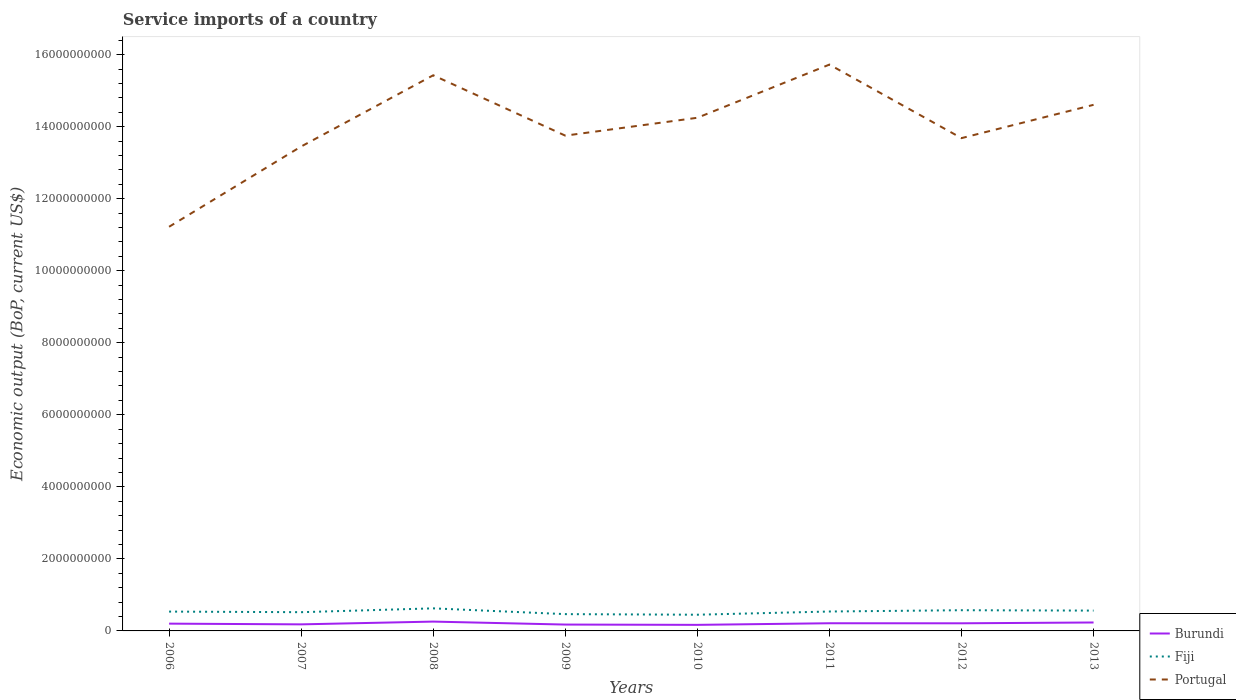Across all years, what is the maximum service imports in Fiji?
Your answer should be compact. 4.50e+08. In which year was the service imports in Portugal maximum?
Your response must be concise. 2006. What is the total service imports in Portugal in the graph?
Offer a very short reply. -4.96e+08. What is the difference between the highest and the second highest service imports in Portugal?
Offer a terse response. 4.50e+09. What is the difference between the highest and the lowest service imports in Fiji?
Offer a very short reply. 5. Is the service imports in Portugal strictly greater than the service imports in Fiji over the years?
Make the answer very short. No. How many lines are there?
Ensure brevity in your answer.  3. How many years are there in the graph?
Offer a terse response. 8. What is the difference between two consecutive major ticks on the Y-axis?
Offer a terse response. 2.00e+09. Does the graph contain any zero values?
Your answer should be very brief. No. Does the graph contain grids?
Keep it short and to the point. No. Where does the legend appear in the graph?
Ensure brevity in your answer.  Bottom right. What is the title of the graph?
Offer a terse response. Service imports of a country. Does "Gambia, The" appear as one of the legend labels in the graph?
Provide a succinct answer. No. What is the label or title of the Y-axis?
Make the answer very short. Economic output (BoP, current US$). What is the Economic output (BoP, current US$) in Burundi in 2006?
Ensure brevity in your answer.  2.02e+08. What is the Economic output (BoP, current US$) in Fiji in 2006?
Provide a succinct answer. 5.37e+08. What is the Economic output (BoP, current US$) of Portugal in 2006?
Offer a very short reply. 1.12e+1. What is the Economic output (BoP, current US$) of Burundi in 2007?
Offer a terse response. 1.82e+08. What is the Economic output (BoP, current US$) in Fiji in 2007?
Your answer should be very brief. 5.20e+08. What is the Economic output (BoP, current US$) of Portugal in 2007?
Ensure brevity in your answer.  1.34e+1. What is the Economic output (BoP, current US$) of Burundi in 2008?
Provide a short and direct response. 2.59e+08. What is the Economic output (BoP, current US$) of Fiji in 2008?
Give a very brief answer. 6.27e+08. What is the Economic output (BoP, current US$) in Portugal in 2008?
Your response must be concise. 1.54e+1. What is the Economic output (BoP, current US$) in Burundi in 2009?
Offer a terse response. 1.77e+08. What is the Economic output (BoP, current US$) in Fiji in 2009?
Your answer should be compact. 4.66e+08. What is the Economic output (BoP, current US$) of Portugal in 2009?
Offer a terse response. 1.38e+1. What is the Economic output (BoP, current US$) in Burundi in 2010?
Your answer should be very brief. 1.68e+08. What is the Economic output (BoP, current US$) in Fiji in 2010?
Offer a very short reply. 4.50e+08. What is the Economic output (BoP, current US$) in Portugal in 2010?
Give a very brief answer. 1.42e+1. What is the Economic output (BoP, current US$) of Burundi in 2011?
Your answer should be compact. 2.13e+08. What is the Economic output (BoP, current US$) in Fiji in 2011?
Ensure brevity in your answer.  5.39e+08. What is the Economic output (BoP, current US$) in Portugal in 2011?
Offer a terse response. 1.57e+1. What is the Economic output (BoP, current US$) of Burundi in 2012?
Make the answer very short. 2.12e+08. What is the Economic output (BoP, current US$) of Fiji in 2012?
Make the answer very short. 5.75e+08. What is the Economic output (BoP, current US$) of Portugal in 2012?
Make the answer very short. 1.37e+1. What is the Economic output (BoP, current US$) in Burundi in 2013?
Your answer should be very brief. 2.34e+08. What is the Economic output (BoP, current US$) in Fiji in 2013?
Make the answer very short. 5.64e+08. What is the Economic output (BoP, current US$) in Portugal in 2013?
Your response must be concise. 1.46e+1. Across all years, what is the maximum Economic output (BoP, current US$) in Burundi?
Your response must be concise. 2.59e+08. Across all years, what is the maximum Economic output (BoP, current US$) in Fiji?
Offer a terse response. 6.27e+08. Across all years, what is the maximum Economic output (BoP, current US$) of Portugal?
Ensure brevity in your answer.  1.57e+1. Across all years, what is the minimum Economic output (BoP, current US$) of Burundi?
Give a very brief answer. 1.68e+08. Across all years, what is the minimum Economic output (BoP, current US$) of Fiji?
Offer a terse response. 4.50e+08. Across all years, what is the minimum Economic output (BoP, current US$) in Portugal?
Keep it short and to the point. 1.12e+1. What is the total Economic output (BoP, current US$) of Burundi in the graph?
Offer a terse response. 1.65e+09. What is the total Economic output (BoP, current US$) in Fiji in the graph?
Give a very brief answer. 4.28e+09. What is the total Economic output (BoP, current US$) of Portugal in the graph?
Your answer should be compact. 1.12e+11. What is the difference between the Economic output (BoP, current US$) in Burundi in 2006 and that in 2007?
Offer a very short reply. 2.01e+07. What is the difference between the Economic output (BoP, current US$) of Fiji in 2006 and that in 2007?
Keep it short and to the point. 1.64e+07. What is the difference between the Economic output (BoP, current US$) of Portugal in 2006 and that in 2007?
Ensure brevity in your answer.  -2.23e+09. What is the difference between the Economic output (BoP, current US$) of Burundi in 2006 and that in 2008?
Provide a succinct answer. -5.65e+07. What is the difference between the Economic output (BoP, current US$) in Fiji in 2006 and that in 2008?
Offer a very short reply. -8.98e+07. What is the difference between the Economic output (BoP, current US$) in Portugal in 2006 and that in 2008?
Offer a very short reply. -4.21e+09. What is the difference between the Economic output (BoP, current US$) in Burundi in 2006 and that in 2009?
Make the answer very short. 2.56e+07. What is the difference between the Economic output (BoP, current US$) of Fiji in 2006 and that in 2009?
Ensure brevity in your answer.  7.06e+07. What is the difference between the Economic output (BoP, current US$) of Portugal in 2006 and that in 2009?
Make the answer very short. -2.53e+09. What is the difference between the Economic output (BoP, current US$) in Burundi in 2006 and that in 2010?
Your answer should be very brief. 3.39e+07. What is the difference between the Economic output (BoP, current US$) in Fiji in 2006 and that in 2010?
Give a very brief answer. 8.69e+07. What is the difference between the Economic output (BoP, current US$) of Portugal in 2006 and that in 2010?
Provide a short and direct response. -3.03e+09. What is the difference between the Economic output (BoP, current US$) of Burundi in 2006 and that in 2011?
Your response must be concise. -1.06e+07. What is the difference between the Economic output (BoP, current US$) of Fiji in 2006 and that in 2011?
Offer a terse response. -2.33e+06. What is the difference between the Economic output (BoP, current US$) of Portugal in 2006 and that in 2011?
Your answer should be compact. -4.50e+09. What is the difference between the Economic output (BoP, current US$) in Burundi in 2006 and that in 2012?
Your response must be concise. -9.36e+06. What is the difference between the Economic output (BoP, current US$) in Fiji in 2006 and that in 2012?
Your answer should be compact. -3.81e+07. What is the difference between the Economic output (BoP, current US$) of Portugal in 2006 and that in 2012?
Your answer should be very brief. -2.46e+09. What is the difference between the Economic output (BoP, current US$) in Burundi in 2006 and that in 2013?
Your answer should be compact. -3.19e+07. What is the difference between the Economic output (BoP, current US$) of Fiji in 2006 and that in 2013?
Your answer should be compact. -2.76e+07. What is the difference between the Economic output (BoP, current US$) in Portugal in 2006 and that in 2013?
Make the answer very short. -3.39e+09. What is the difference between the Economic output (BoP, current US$) of Burundi in 2007 and that in 2008?
Ensure brevity in your answer.  -7.66e+07. What is the difference between the Economic output (BoP, current US$) in Fiji in 2007 and that in 2008?
Your answer should be very brief. -1.06e+08. What is the difference between the Economic output (BoP, current US$) of Portugal in 2007 and that in 2008?
Make the answer very short. -1.98e+09. What is the difference between the Economic output (BoP, current US$) of Burundi in 2007 and that in 2009?
Your answer should be compact. 5.50e+06. What is the difference between the Economic output (BoP, current US$) in Fiji in 2007 and that in 2009?
Offer a terse response. 5.41e+07. What is the difference between the Economic output (BoP, current US$) of Portugal in 2007 and that in 2009?
Your response must be concise. -3.01e+08. What is the difference between the Economic output (BoP, current US$) in Burundi in 2007 and that in 2010?
Provide a succinct answer. 1.38e+07. What is the difference between the Economic output (BoP, current US$) in Fiji in 2007 and that in 2010?
Offer a terse response. 7.04e+07. What is the difference between the Economic output (BoP, current US$) in Portugal in 2007 and that in 2010?
Keep it short and to the point. -7.98e+08. What is the difference between the Economic output (BoP, current US$) of Burundi in 2007 and that in 2011?
Give a very brief answer. -3.07e+07. What is the difference between the Economic output (BoP, current US$) in Fiji in 2007 and that in 2011?
Offer a very short reply. -1.88e+07. What is the difference between the Economic output (BoP, current US$) in Portugal in 2007 and that in 2011?
Keep it short and to the point. -2.27e+09. What is the difference between the Economic output (BoP, current US$) of Burundi in 2007 and that in 2012?
Ensure brevity in your answer.  -2.95e+07. What is the difference between the Economic output (BoP, current US$) in Fiji in 2007 and that in 2012?
Make the answer very short. -5.45e+07. What is the difference between the Economic output (BoP, current US$) in Portugal in 2007 and that in 2012?
Make the answer very short. -2.32e+08. What is the difference between the Economic output (BoP, current US$) in Burundi in 2007 and that in 2013?
Keep it short and to the point. -5.20e+07. What is the difference between the Economic output (BoP, current US$) in Fiji in 2007 and that in 2013?
Ensure brevity in your answer.  -4.41e+07. What is the difference between the Economic output (BoP, current US$) in Portugal in 2007 and that in 2013?
Offer a very short reply. -1.16e+09. What is the difference between the Economic output (BoP, current US$) in Burundi in 2008 and that in 2009?
Provide a succinct answer. 8.21e+07. What is the difference between the Economic output (BoP, current US$) of Fiji in 2008 and that in 2009?
Offer a terse response. 1.60e+08. What is the difference between the Economic output (BoP, current US$) in Portugal in 2008 and that in 2009?
Provide a succinct answer. 1.68e+09. What is the difference between the Economic output (BoP, current US$) in Burundi in 2008 and that in 2010?
Keep it short and to the point. 9.04e+07. What is the difference between the Economic output (BoP, current US$) in Fiji in 2008 and that in 2010?
Your answer should be very brief. 1.77e+08. What is the difference between the Economic output (BoP, current US$) of Portugal in 2008 and that in 2010?
Make the answer very short. 1.18e+09. What is the difference between the Economic output (BoP, current US$) of Burundi in 2008 and that in 2011?
Provide a succinct answer. 4.59e+07. What is the difference between the Economic output (BoP, current US$) in Fiji in 2008 and that in 2011?
Offer a terse response. 8.75e+07. What is the difference between the Economic output (BoP, current US$) in Portugal in 2008 and that in 2011?
Offer a very short reply. -2.97e+08. What is the difference between the Economic output (BoP, current US$) in Burundi in 2008 and that in 2012?
Provide a short and direct response. 4.72e+07. What is the difference between the Economic output (BoP, current US$) in Fiji in 2008 and that in 2012?
Make the answer very short. 5.17e+07. What is the difference between the Economic output (BoP, current US$) in Portugal in 2008 and that in 2012?
Keep it short and to the point. 1.74e+09. What is the difference between the Economic output (BoP, current US$) in Burundi in 2008 and that in 2013?
Your response must be concise. 2.46e+07. What is the difference between the Economic output (BoP, current US$) in Fiji in 2008 and that in 2013?
Offer a very short reply. 6.22e+07. What is the difference between the Economic output (BoP, current US$) in Portugal in 2008 and that in 2013?
Give a very brief answer. 8.20e+08. What is the difference between the Economic output (BoP, current US$) in Burundi in 2009 and that in 2010?
Your answer should be compact. 8.29e+06. What is the difference between the Economic output (BoP, current US$) of Fiji in 2009 and that in 2010?
Give a very brief answer. 1.63e+07. What is the difference between the Economic output (BoP, current US$) of Portugal in 2009 and that in 2010?
Provide a short and direct response. -4.96e+08. What is the difference between the Economic output (BoP, current US$) in Burundi in 2009 and that in 2011?
Provide a succinct answer. -3.62e+07. What is the difference between the Economic output (BoP, current US$) in Fiji in 2009 and that in 2011?
Your response must be concise. -7.29e+07. What is the difference between the Economic output (BoP, current US$) of Portugal in 2009 and that in 2011?
Your answer should be very brief. -1.97e+09. What is the difference between the Economic output (BoP, current US$) of Burundi in 2009 and that in 2012?
Your answer should be compact. -3.49e+07. What is the difference between the Economic output (BoP, current US$) of Fiji in 2009 and that in 2012?
Give a very brief answer. -1.09e+08. What is the difference between the Economic output (BoP, current US$) of Portugal in 2009 and that in 2012?
Offer a very short reply. 6.92e+07. What is the difference between the Economic output (BoP, current US$) of Burundi in 2009 and that in 2013?
Ensure brevity in your answer.  -5.75e+07. What is the difference between the Economic output (BoP, current US$) in Fiji in 2009 and that in 2013?
Provide a short and direct response. -9.82e+07. What is the difference between the Economic output (BoP, current US$) in Portugal in 2009 and that in 2013?
Your response must be concise. -8.56e+08. What is the difference between the Economic output (BoP, current US$) of Burundi in 2010 and that in 2011?
Offer a very short reply. -4.45e+07. What is the difference between the Economic output (BoP, current US$) in Fiji in 2010 and that in 2011?
Offer a terse response. -8.92e+07. What is the difference between the Economic output (BoP, current US$) in Portugal in 2010 and that in 2011?
Offer a terse response. -1.48e+09. What is the difference between the Economic output (BoP, current US$) of Burundi in 2010 and that in 2012?
Your answer should be compact. -4.32e+07. What is the difference between the Economic output (BoP, current US$) of Fiji in 2010 and that in 2012?
Ensure brevity in your answer.  -1.25e+08. What is the difference between the Economic output (BoP, current US$) of Portugal in 2010 and that in 2012?
Offer a terse response. 5.66e+08. What is the difference between the Economic output (BoP, current US$) in Burundi in 2010 and that in 2013?
Ensure brevity in your answer.  -6.58e+07. What is the difference between the Economic output (BoP, current US$) in Fiji in 2010 and that in 2013?
Offer a very short reply. -1.14e+08. What is the difference between the Economic output (BoP, current US$) of Portugal in 2010 and that in 2013?
Offer a very short reply. -3.59e+08. What is the difference between the Economic output (BoP, current US$) of Burundi in 2011 and that in 2012?
Ensure brevity in your answer.  1.27e+06. What is the difference between the Economic output (BoP, current US$) in Fiji in 2011 and that in 2012?
Your answer should be very brief. -3.57e+07. What is the difference between the Economic output (BoP, current US$) in Portugal in 2011 and that in 2012?
Give a very brief answer. 2.04e+09. What is the difference between the Economic output (BoP, current US$) in Burundi in 2011 and that in 2013?
Keep it short and to the point. -2.13e+07. What is the difference between the Economic output (BoP, current US$) of Fiji in 2011 and that in 2013?
Keep it short and to the point. -2.53e+07. What is the difference between the Economic output (BoP, current US$) of Portugal in 2011 and that in 2013?
Your answer should be very brief. 1.12e+09. What is the difference between the Economic output (BoP, current US$) in Burundi in 2012 and that in 2013?
Your answer should be very brief. -2.26e+07. What is the difference between the Economic output (BoP, current US$) of Fiji in 2012 and that in 2013?
Provide a short and direct response. 1.05e+07. What is the difference between the Economic output (BoP, current US$) of Portugal in 2012 and that in 2013?
Keep it short and to the point. -9.25e+08. What is the difference between the Economic output (BoP, current US$) in Burundi in 2006 and the Economic output (BoP, current US$) in Fiji in 2007?
Provide a short and direct response. -3.18e+08. What is the difference between the Economic output (BoP, current US$) in Burundi in 2006 and the Economic output (BoP, current US$) in Portugal in 2007?
Your answer should be compact. -1.32e+1. What is the difference between the Economic output (BoP, current US$) in Fiji in 2006 and the Economic output (BoP, current US$) in Portugal in 2007?
Offer a very short reply. -1.29e+1. What is the difference between the Economic output (BoP, current US$) in Burundi in 2006 and the Economic output (BoP, current US$) in Fiji in 2008?
Offer a very short reply. -4.24e+08. What is the difference between the Economic output (BoP, current US$) of Burundi in 2006 and the Economic output (BoP, current US$) of Portugal in 2008?
Ensure brevity in your answer.  -1.52e+1. What is the difference between the Economic output (BoP, current US$) in Fiji in 2006 and the Economic output (BoP, current US$) in Portugal in 2008?
Make the answer very short. -1.49e+1. What is the difference between the Economic output (BoP, current US$) in Burundi in 2006 and the Economic output (BoP, current US$) in Fiji in 2009?
Provide a short and direct response. -2.64e+08. What is the difference between the Economic output (BoP, current US$) of Burundi in 2006 and the Economic output (BoP, current US$) of Portugal in 2009?
Your response must be concise. -1.35e+1. What is the difference between the Economic output (BoP, current US$) in Fiji in 2006 and the Economic output (BoP, current US$) in Portugal in 2009?
Your answer should be very brief. -1.32e+1. What is the difference between the Economic output (BoP, current US$) of Burundi in 2006 and the Economic output (BoP, current US$) of Fiji in 2010?
Keep it short and to the point. -2.48e+08. What is the difference between the Economic output (BoP, current US$) in Burundi in 2006 and the Economic output (BoP, current US$) in Portugal in 2010?
Your response must be concise. -1.40e+1. What is the difference between the Economic output (BoP, current US$) in Fiji in 2006 and the Economic output (BoP, current US$) in Portugal in 2010?
Offer a terse response. -1.37e+1. What is the difference between the Economic output (BoP, current US$) of Burundi in 2006 and the Economic output (BoP, current US$) of Fiji in 2011?
Give a very brief answer. -3.37e+08. What is the difference between the Economic output (BoP, current US$) in Burundi in 2006 and the Economic output (BoP, current US$) in Portugal in 2011?
Your answer should be compact. -1.55e+1. What is the difference between the Economic output (BoP, current US$) in Fiji in 2006 and the Economic output (BoP, current US$) in Portugal in 2011?
Provide a succinct answer. -1.52e+1. What is the difference between the Economic output (BoP, current US$) of Burundi in 2006 and the Economic output (BoP, current US$) of Fiji in 2012?
Offer a very short reply. -3.73e+08. What is the difference between the Economic output (BoP, current US$) of Burundi in 2006 and the Economic output (BoP, current US$) of Portugal in 2012?
Your response must be concise. -1.35e+1. What is the difference between the Economic output (BoP, current US$) of Fiji in 2006 and the Economic output (BoP, current US$) of Portugal in 2012?
Keep it short and to the point. -1.31e+1. What is the difference between the Economic output (BoP, current US$) in Burundi in 2006 and the Economic output (BoP, current US$) in Fiji in 2013?
Your answer should be compact. -3.62e+08. What is the difference between the Economic output (BoP, current US$) of Burundi in 2006 and the Economic output (BoP, current US$) of Portugal in 2013?
Provide a succinct answer. -1.44e+1. What is the difference between the Economic output (BoP, current US$) in Fiji in 2006 and the Economic output (BoP, current US$) in Portugal in 2013?
Make the answer very short. -1.41e+1. What is the difference between the Economic output (BoP, current US$) of Burundi in 2007 and the Economic output (BoP, current US$) of Fiji in 2008?
Provide a short and direct response. -4.44e+08. What is the difference between the Economic output (BoP, current US$) of Burundi in 2007 and the Economic output (BoP, current US$) of Portugal in 2008?
Your response must be concise. -1.52e+1. What is the difference between the Economic output (BoP, current US$) of Fiji in 2007 and the Economic output (BoP, current US$) of Portugal in 2008?
Provide a succinct answer. -1.49e+1. What is the difference between the Economic output (BoP, current US$) of Burundi in 2007 and the Economic output (BoP, current US$) of Fiji in 2009?
Ensure brevity in your answer.  -2.84e+08. What is the difference between the Economic output (BoP, current US$) in Burundi in 2007 and the Economic output (BoP, current US$) in Portugal in 2009?
Your response must be concise. -1.36e+1. What is the difference between the Economic output (BoP, current US$) of Fiji in 2007 and the Economic output (BoP, current US$) of Portugal in 2009?
Ensure brevity in your answer.  -1.32e+1. What is the difference between the Economic output (BoP, current US$) in Burundi in 2007 and the Economic output (BoP, current US$) in Fiji in 2010?
Provide a short and direct response. -2.68e+08. What is the difference between the Economic output (BoP, current US$) of Burundi in 2007 and the Economic output (BoP, current US$) of Portugal in 2010?
Provide a short and direct response. -1.41e+1. What is the difference between the Economic output (BoP, current US$) of Fiji in 2007 and the Economic output (BoP, current US$) of Portugal in 2010?
Offer a terse response. -1.37e+1. What is the difference between the Economic output (BoP, current US$) in Burundi in 2007 and the Economic output (BoP, current US$) in Fiji in 2011?
Your response must be concise. -3.57e+08. What is the difference between the Economic output (BoP, current US$) in Burundi in 2007 and the Economic output (BoP, current US$) in Portugal in 2011?
Make the answer very short. -1.55e+1. What is the difference between the Economic output (BoP, current US$) in Fiji in 2007 and the Economic output (BoP, current US$) in Portugal in 2011?
Your response must be concise. -1.52e+1. What is the difference between the Economic output (BoP, current US$) of Burundi in 2007 and the Economic output (BoP, current US$) of Fiji in 2012?
Offer a very short reply. -3.93e+08. What is the difference between the Economic output (BoP, current US$) of Burundi in 2007 and the Economic output (BoP, current US$) of Portugal in 2012?
Ensure brevity in your answer.  -1.35e+1. What is the difference between the Economic output (BoP, current US$) of Fiji in 2007 and the Economic output (BoP, current US$) of Portugal in 2012?
Make the answer very short. -1.32e+1. What is the difference between the Economic output (BoP, current US$) in Burundi in 2007 and the Economic output (BoP, current US$) in Fiji in 2013?
Offer a terse response. -3.82e+08. What is the difference between the Economic output (BoP, current US$) of Burundi in 2007 and the Economic output (BoP, current US$) of Portugal in 2013?
Make the answer very short. -1.44e+1. What is the difference between the Economic output (BoP, current US$) in Fiji in 2007 and the Economic output (BoP, current US$) in Portugal in 2013?
Your answer should be compact. -1.41e+1. What is the difference between the Economic output (BoP, current US$) of Burundi in 2008 and the Economic output (BoP, current US$) of Fiji in 2009?
Offer a very short reply. -2.07e+08. What is the difference between the Economic output (BoP, current US$) of Burundi in 2008 and the Economic output (BoP, current US$) of Portugal in 2009?
Give a very brief answer. -1.35e+1. What is the difference between the Economic output (BoP, current US$) in Fiji in 2008 and the Economic output (BoP, current US$) in Portugal in 2009?
Make the answer very short. -1.31e+1. What is the difference between the Economic output (BoP, current US$) in Burundi in 2008 and the Economic output (BoP, current US$) in Fiji in 2010?
Offer a very short reply. -1.91e+08. What is the difference between the Economic output (BoP, current US$) of Burundi in 2008 and the Economic output (BoP, current US$) of Portugal in 2010?
Your answer should be very brief. -1.40e+1. What is the difference between the Economic output (BoP, current US$) of Fiji in 2008 and the Economic output (BoP, current US$) of Portugal in 2010?
Offer a very short reply. -1.36e+1. What is the difference between the Economic output (BoP, current US$) of Burundi in 2008 and the Economic output (BoP, current US$) of Fiji in 2011?
Keep it short and to the point. -2.80e+08. What is the difference between the Economic output (BoP, current US$) in Burundi in 2008 and the Economic output (BoP, current US$) in Portugal in 2011?
Provide a succinct answer. -1.55e+1. What is the difference between the Economic output (BoP, current US$) of Fiji in 2008 and the Economic output (BoP, current US$) of Portugal in 2011?
Your answer should be compact. -1.51e+1. What is the difference between the Economic output (BoP, current US$) of Burundi in 2008 and the Economic output (BoP, current US$) of Fiji in 2012?
Offer a terse response. -3.16e+08. What is the difference between the Economic output (BoP, current US$) in Burundi in 2008 and the Economic output (BoP, current US$) in Portugal in 2012?
Give a very brief answer. -1.34e+1. What is the difference between the Economic output (BoP, current US$) in Fiji in 2008 and the Economic output (BoP, current US$) in Portugal in 2012?
Your answer should be compact. -1.31e+1. What is the difference between the Economic output (BoP, current US$) of Burundi in 2008 and the Economic output (BoP, current US$) of Fiji in 2013?
Keep it short and to the point. -3.06e+08. What is the difference between the Economic output (BoP, current US$) of Burundi in 2008 and the Economic output (BoP, current US$) of Portugal in 2013?
Offer a very short reply. -1.43e+1. What is the difference between the Economic output (BoP, current US$) of Fiji in 2008 and the Economic output (BoP, current US$) of Portugal in 2013?
Provide a short and direct response. -1.40e+1. What is the difference between the Economic output (BoP, current US$) of Burundi in 2009 and the Economic output (BoP, current US$) of Fiji in 2010?
Give a very brief answer. -2.73e+08. What is the difference between the Economic output (BoP, current US$) in Burundi in 2009 and the Economic output (BoP, current US$) in Portugal in 2010?
Offer a terse response. -1.41e+1. What is the difference between the Economic output (BoP, current US$) of Fiji in 2009 and the Economic output (BoP, current US$) of Portugal in 2010?
Provide a short and direct response. -1.38e+1. What is the difference between the Economic output (BoP, current US$) of Burundi in 2009 and the Economic output (BoP, current US$) of Fiji in 2011?
Offer a very short reply. -3.62e+08. What is the difference between the Economic output (BoP, current US$) of Burundi in 2009 and the Economic output (BoP, current US$) of Portugal in 2011?
Provide a succinct answer. -1.55e+1. What is the difference between the Economic output (BoP, current US$) in Fiji in 2009 and the Economic output (BoP, current US$) in Portugal in 2011?
Offer a terse response. -1.53e+1. What is the difference between the Economic output (BoP, current US$) of Burundi in 2009 and the Economic output (BoP, current US$) of Fiji in 2012?
Your response must be concise. -3.98e+08. What is the difference between the Economic output (BoP, current US$) of Burundi in 2009 and the Economic output (BoP, current US$) of Portugal in 2012?
Make the answer very short. -1.35e+1. What is the difference between the Economic output (BoP, current US$) of Fiji in 2009 and the Economic output (BoP, current US$) of Portugal in 2012?
Offer a terse response. -1.32e+1. What is the difference between the Economic output (BoP, current US$) in Burundi in 2009 and the Economic output (BoP, current US$) in Fiji in 2013?
Your answer should be compact. -3.88e+08. What is the difference between the Economic output (BoP, current US$) of Burundi in 2009 and the Economic output (BoP, current US$) of Portugal in 2013?
Keep it short and to the point. -1.44e+1. What is the difference between the Economic output (BoP, current US$) of Fiji in 2009 and the Economic output (BoP, current US$) of Portugal in 2013?
Your response must be concise. -1.41e+1. What is the difference between the Economic output (BoP, current US$) of Burundi in 2010 and the Economic output (BoP, current US$) of Fiji in 2011?
Provide a short and direct response. -3.71e+08. What is the difference between the Economic output (BoP, current US$) in Burundi in 2010 and the Economic output (BoP, current US$) in Portugal in 2011?
Your answer should be compact. -1.56e+1. What is the difference between the Economic output (BoP, current US$) of Fiji in 2010 and the Economic output (BoP, current US$) of Portugal in 2011?
Your answer should be compact. -1.53e+1. What is the difference between the Economic output (BoP, current US$) in Burundi in 2010 and the Economic output (BoP, current US$) in Fiji in 2012?
Make the answer very short. -4.06e+08. What is the difference between the Economic output (BoP, current US$) of Burundi in 2010 and the Economic output (BoP, current US$) of Portugal in 2012?
Provide a short and direct response. -1.35e+1. What is the difference between the Economic output (BoP, current US$) of Fiji in 2010 and the Economic output (BoP, current US$) of Portugal in 2012?
Your answer should be compact. -1.32e+1. What is the difference between the Economic output (BoP, current US$) in Burundi in 2010 and the Economic output (BoP, current US$) in Fiji in 2013?
Give a very brief answer. -3.96e+08. What is the difference between the Economic output (BoP, current US$) of Burundi in 2010 and the Economic output (BoP, current US$) of Portugal in 2013?
Provide a short and direct response. -1.44e+1. What is the difference between the Economic output (BoP, current US$) of Fiji in 2010 and the Economic output (BoP, current US$) of Portugal in 2013?
Your answer should be very brief. -1.42e+1. What is the difference between the Economic output (BoP, current US$) of Burundi in 2011 and the Economic output (BoP, current US$) of Fiji in 2012?
Your answer should be compact. -3.62e+08. What is the difference between the Economic output (BoP, current US$) of Burundi in 2011 and the Economic output (BoP, current US$) of Portugal in 2012?
Offer a terse response. -1.35e+1. What is the difference between the Economic output (BoP, current US$) of Fiji in 2011 and the Economic output (BoP, current US$) of Portugal in 2012?
Provide a succinct answer. -1.31e+1. What is the difference between the Economic output (BoP, current US$) in Burundi in 2011 and the Economic output (BoP, current US$) in Fiji in 2013?
Ensure brevity in your answer.  -3.51e+08. What is the difference between the Economic output (BoP, current US$) in Burundi in 2011 and the Economic output (BoP, current US$) in Portugal in 2013?
Make the answer very short. -1.44e+1. What is the difference between the Economic output (BoP, current US$) in Fiji in 2011 and the Economic output (BoP, current US$) in Portugal in 2013?
Provide a short and direct response. -1.41e+1. What is the difference between the Economic output (BoP, current US$) of Burundi in 2012 and the Economic output (BoP, current US$) of Fiji in 2013?
Your response must be concise. -3.53e+08. What is the difference between the Economic output (BoP, current US$) of Burundi in 2012 and the Economic output (BoP, current US$) of Portugal in 2013?
Keep it short and to the point. -1.44e+1. What is the difference between the Economic output (BoP, current US$) of Fiji in 2012 and the Economic output (BoP, current US$) of Portugal in 2013?
Your answer should be compact. -1.40e+1. What is the average Economic output (BoP, current US$) of Burundi per year?
Your response must be concise. 2.06e+08. What is the average Economic output (BoP, current US$) of Fiji per year?
Offer a terse response. 5.35e+08. What is the average Economic output (BoP, current US$) in Portugal per year?
Give a very brief answer. 1.40e+1. In the year 2006, what is the difference between the Economic output (BoP, current US$) in Burundi and Economic output (BoP, current US$) in Fiji?
Provide a short and direct response. -3.34e+08. In the year 2006, what is the difference between the Economic output (BoP, current US$) of Burundi and Economic output (BoP, current US$) of Portugal?
Provide a short and direct response. -1.10e+1. In the year 2006, what is the difference between the Economic output (BoP, current US$) of Fiji and Economic output (BoP, current US$) of Portugal?
Keep it short and to the point. -1.07e+1. In the year 2007, what is the difference between the Economic output (BoP, current US$) in Burundi and Economic output (BoP, current US$) in Fiji?
Provide a succinct answer. -3.38e+08. In the year 2007, what is the difference between the Economic output (BoP, current US$) of Burundi and Economic output (BoP, current US$) of Portugal?
Offer a terse response. -1.33e+1. In the year 2007, what is the difference between the Economic output (BoP, current US$) of Fiji and Economic output (BoP, current US$) of Portugal?
Provide a succinct answer. -1.29e+1. In the year 2008, what is the difference between the Economic output (BoP, current US$) in Burundi and Economic output (BoP, current US$) in Fiji?
Provide a short and direct response. -3.68e+08. In the year 2008, what is the difference between the Economic output (BoP, current US$) in Burundi and Economic output (BoP, current US$) in Portugal?
Make the answer very short. -1.52e+1. In the year 2008, what is the difference between the Economic output (BoP, current US$) of Fiji and Economic output (BoP, current US$) of Portugal?
Provide a short and direct response. -1.48e+1. In the year 2009, what is the difference between the Economic output (BoP, current US$) in Burundi and Economic output (BoP, current US$) in Fiji?
Your answer should be compact. -2.90e+08. In the year 2009, what is the difference between the Economic output (BoP, current US$) in Burundi and Economic output (BoP, current US$) in Portugal?
Your response must be concise. -1.36e+1. In the year 2009, what is the difference between the Economic output (BoP, current US$) in Fiji and Economic output (BoP, current US$) in Portugal?
Offer a very short reply. -1.33e+1. In the year 2010, what is the difference between the Economic output (BoP, current US$) of Burundi and Economic output (BoP, current US$) of Fiji?
Ensure brevity in your answer.  -2.82e+08. In the year 2010, what is the difference between the Economic output (BoP, current US$) of Burundi and Economic output (BoP, current US$) of Portugal?
Ensure brevity in your answer.  -1.41e+1. In the year 2010, what is the difference between the Economic output (BoP, current US$) in Fiji and Economic output (BoP, current US$) in Portugal?
Ensure brevity in your answer.  -1.38e+1. In the year 2011, what is the difference between the Economic output (BoP, current US$) of Burundi and Economic output (BoP, current US$) of Fiji?
Your answer should be very brief. -3.26e+08. In the year 2011, what is the difference between the Economic output (BoP, current US$) in Burundi and Economic output (BoP, current US$) in Portugal?
Ensure brevity in your answer.  -1.55e+1. In the year 2011, what is the difference between the Economic output (BoP, current US$) in Fiji and Economic output (BoP, current US$) in Portugal?
Provide a short and direct response. -1.52e+1. In the year 2012, what is the difference between the Economic output (BoP, current US$) of Burundi and Economic output (BoP, current US$) of Fiji?
Offer a very short reply. -3.63e+08. In the year 2012, what is the difference between the Economic output (BoP, current US$) in Burundi and Economic output (BoP, current US$) in Portugal?
Make the answer very short. -1.35e+1. In the year 2012, what is the difference between the Economic output (BoP, current US$) in Fiji and Economic output (BoP, current US$) in Portugal?
Provide a short and direct response. -1.31e+1. In the year 2013, what is the difference between the Economic output (BoP, current US$) in Burundi and Economic output (BoP, current US$) in Fiji?
Ensure brevity in your answer.  -3.30e+08. In the year 2013, what is the difference between the Economic output (BoP, current US$) in Burundi and Economic output (BoP, current US$) in Portugal?
Provide a short and direct response. -1.44e+1. In the year 2013, what is the difference between the Economic output (BoP, current US$) in Fiji and Economic output (BoP, current US$) in Portugal?
Your answer should be compact. -1.40e+1. What is the ratio of the Economic output (BoP, current US$) of Burundi in 2006 to that in 2007?
Make the answer very short. 1.11. What is the ratio of the Economic output (BoP, current US$) of Fiji in 2006 to that in 2007?
Give a very brief answer. 1.03. What is the ratio of the Economic output (BoP, current US$) in Portugal in 2006 to that in 2007?
Give a very brief answer. 0.83. What is the ratio of the Economic output (BoP, current US$) of Burundi in 2006 to that in 2008?
Your response must be concise. 0.78. What is the ratio of the Economic output (BoP, current US$) of Fiji in 2006 to that in 2008?
Provide a short and direct response. 0.86. What is the ratio of the Economic output (BoP, current US$) of Portugal in 2006 to that in 2008?
Your answer should be compact. 0.73. What is the ratio of the Economic output (BoP, current US$) of Burundi in 2006 to that in 2009?
Your answer should be compact. 1.14. What is the ratio of the Economic output (BoP, current US$) in Fiji in 2006 to that in 2009?
Provide a short and direct response. 1.15. What is the ratio of the Economic output (BoP, current US$) of Portugal in 2006 to that in 2009?
Your answer should be compact. 0.82. What is the ratio of the Economic output (BoP, current US$) of Burundi in 2006 to that in 2010?
Ensure brevity in your answer.  1.2. What is the ratio of the Economic output (BoP, current US$) in Fiji in 2006 to that in 2010?
Offer a terse response. 1.19. What is the ratio of the Economic output (BoP, current US$) in Portugal in 2006 to that in 2010?
Your response must be concise. 0.79. What is the ratio of the Economic output (BoP, current US$) of Burundi in 2006 to that in 2011?
Give a very brief answer. 0.95. What is the ratio of the Economic output (BoP, current US$) in Fiji in 2006 to that in 2011?
Offer a very short reply. 1. What is the ratio of the Economic output (BoP, current US$) of Portugal in 2006 to that in 2011?
Offer a terse response. 0.71. What is the ratio of the Economic output (BoP, current US$) in Burundi in 2006 to that in 2012?
Offer a terse response. 0.96. What is the ratio of the Economic output (BoP, current US$) in Fiji in 2006 to that in 2012?
Your answer should be compact. 0.93. What is the ratio of the Economic output (BoP, current US$) in Portugal in 2006 to that in 2012?
Offer a terse response. 0.82. What is the ratio of the Economic output (BoP, current US$) in Burundi in 2006 to that in 2013?
Keep it short and to the point. 0.86. What is the ratio of the Economic output (BoP, current US$) in Fiji in 2006 to that in 2013?
Your answer should be very brief. 0.95. What is the ratio of the Economic output (BoP, current US$) of Portugal in 2006 to that in 2013?
Provide a short and direct response. 0.77. What is the ratio of the Economic output (BoP, current US$) of Burundi in 2007 to that in 2008?
Your answer should be compact. 0.7. What is the ratio of the Economic output (BoP, current US$) in Fiji in 2007 to that in 2008?
Offer a terse response. 0.83. What is the ratio of the Economic output (BoP, current US$) in Portugal in 2007 to that in 2008?
Your answer should be very brief. 0.87. What is the ratio of the Economic output (BoP, current US$) in Burundi in 2007 to that in 2009?
Provide a succinct answer. 1.03. What is the ratio of the Economic output (BoP, current US$) in Fiji in 2007 to that in 2009?
Keep it short and to the point. 1.12. What is the ratio of the Economic output (BoP, current US$) in Portugal in 2007 to that in 2009?
Provide a succinct answer. 0.98. What is the ratio of the Economic output (BoP, current US$) of Burundi in 2007 to that in 2010?
Your answer should be compact. 1.08. What is the ratio of the Economic output (BoP, current US$) of Fiji in 2007 to that in 2010?
Ensure brevity in your answer.  1.16. What is the ratio of the Economic output (BoP, current US$) in Portugal in 2007 to that in 2010?
Your answer should be very brief. 0.94. What is the ratio of the Economic output (BoP, current US$) in Burundi in 2007 to that in 2011?
Your answer should be very brief. 0.86. What is the ratio of the Economic output (BoP, current US$) of Fiji in 2007 to that in 2011?
Ensure brevity in your answer.  0.97. What is the ratio of the Economic output (BoP, current US$) in Portugal in 2007 to that in 2011?
Your answer should be very brief. 0.86. What is the ratio of the Economic output (BoP, current US$) in Burundi in 2007 to that in 2012?
Provide a short and direct response. 0.86. What is the ratio of the Economic output (BoP, current US$) of Fiji in 2007 to that in 2012?
Offer a terse response. 0.91. What is the ratio of the Economic output (BoP, current US$) of Burundi in 2007 to that in 2013?
Your answer should be compact. 0.78. What is the ratio of the Economic output (BoP, current US$) in Fiji in 2007 to that in 2013?
Make the answer very short. 0.92. What is the ratio of the Economic output (BoP, current US$) of Portugal in 2007 to that in 2013?
Provide a succinct answer. 0.92. What is the ratio of the Economic output (BoP, current US$) in Burundi in 2008 to that in 2009?
Make the answer very short. 1.47. What is the ratio of the Economic output (BoP, current US$) of Fiji in 2008 to that in 2009?
Ensure brevity in your answer.  1.34. What is the ratio of the Economic output (BoP, current US$) in Portugal in 2008 to that in 2009?
Provide a succinct answer. 1.12. What is the ratio of the Economic output (BoP, current US$) of Burundi in 2008 to that in 2010?
Your response must be concise. 1.54. What is the ratio of the Economic output (BoP, current US$) of Fiji in 2008 to that in 2010?
Provide a short and direct response. 1.39. What is the ratio of the Economic output (BoP, current US$) of Portugal in 2008 to that in 2010?
Offer a very short reply. 1.08. What is the ratio of the Economic output (BoP, current US$) of Burundi in 2008 to that in 2011?
Offer a very short reply. 1.22. What is the ratio of the Economic output (BoP, current US$) of Fiji in 2008 to that in 2011?
Provide a short and direct response. 1.16. What is the ratio of the Economic output (BoP, current US$) of Portugal in 2008 to that in 2011?
Give a very brief answer. 0.98. What is the ratio of the Economic output (BoP, current US$) in Burundi in 2008 to that in 2012?
Your answer should be very brief. 1.22. What is the ratio of the Economic output (BoP, current US$) of Fiji in 2008 to that in 2012?
Your answer should be very brief. 1.09. What is the ratio of the Economic output (BoP, current US$) in Portugal in 2008 to that in 2012?
Ensure brevity in your answer.  1.13. What is the ratio of the Economic output (BoP, current US$) in Burundi in 2008 to that in 2013?
Your answer should be compact. 1.11. What is the ratio of the Economic output (BoP, current US$) of Fiji in 2008 to that in 2013?
Offer a very short reply. 1.11. What is the ratio of the Economic output (BoP, current US$) of Portugal in 2008 to that in 2013?
Your response must be concise. 1.06. What is the ratio of the Economic output (BoP, current US$) of Burundi in 2009 to that in 2010?
Give a very brief answer. 1.05. What is the ratio of the Economic output (BoP, current US$) of Fiji in 2009 to that in 2010?
Give a very brief answer. 1.04. What is the ratio of the Economic output (BoP, current US$) of Portugal in 2009 to that in 2010?
Keep it short and to the point. 0.97. What is the ratio of the Economic output (BoP, current US$) in Burundi in 2009 to that in 2011?
Offer a very short reply. 0.83. What is the ratio of the Economic output (BoP, current US$) in Fiji in 2009 to that in 2011?
Your response must be concise. 0.86. What is the ratio of the Economic output (BoP, current US$) of Portugal in 2009 to that in 2011?
Your response must be concise. 0.87. What is the ratio of the Economic output (BoP, current US$) of Burundi in 2009 to that in 2012?
Ensure brevity in your answer.  0.83. What is the ratio of the Economic output (BoP, current US$) in Fiji in 2009 to that in 2012?
Offer a very short reply. 0.81. What is the ratio of the Economic output (BoP, current US$) of Portugal in 2009 to that in 2012?
Your answer should be very brief. 1.01. What is the ratio of the Economic output (BoP, current US$) in Burundi in 2009 to that in 2013?
Offer a terse response. 0.75. What is the ratio of the Economic output (BoP, current US$) in Fiji in 2009 to that in 2013?
Offer a very short reply. 0.83. What is the ratio of the Economic output (BoP, current US$) of Portugal in 2009 to that in 2013?
Provide a succinct answer. 0.94. What is the ratio of the Economic output (BoP, current US$) of Burundi in 2010 to that in 2011?
Provide a short and direct response. 0.79. What is the ratio of the Economic output (BoP, current US$) in Fiji in 2010 to that in 2011?
Your response must be concise. 0.83. What is the ratio of the Economic output (BoP, current US$) of Portugal in 2010 to that in 2011?
Your response must be concise. 0.91. What is the ratio of the Economic output (BoP, current US$) in Burundi in 2010 to that in 2012?
Your response must be concise. 0.8. What is the ratio of the Economic output (BoP, current US$) of Fiji in 2010 to that in 2012?
Provide a short and direct response. 0.78. What is the ratio of the Economic output (BoP, current US$) in Portugal in 2010 to that in 2012?
Provide a succinct answer. 1.04. What is the ratio of the Economic output (BoP, current US$) of Burundi in 2010 to that in 2013?
Make the answer very short. 0.72. What is the ratio of the Economic output (BoP, current US$) of Fiji in 2010 to that in 2013?
Provide a short and direct response. 0.8. What is the ratio of the Economic output (BoP, current US$) of Portugal in 2010 to that in 2013?
Your answer should be very brief. 0.98. What is the ratio of the Economic output (BoP, current US$) of Burundi in 2011 to that in 2012?
Provide a short and direct response. 1.01. What is the ratio of the Economic output (BoP, current US$) of Fiji in 2011 to that in 2012?
Provide a succinct answer. 0.94. What is the ratio of the Economic output (BoP, current US$) of Portugal in 2011 to that in 2012?
Your response must be concise. 1.15. What is the ratio of the Economic output (BoP, current US$) of Burundi in 2011 to that in 2013?
Make the answer very short. 0.91. What is the ratio of the Economic output (BoP, current US$) in Fiji in 2011 to that in 2013?
Keep it short and to the point. 0.96. What is the ratio of the Economic output (BoP, current US$) in Portugal in 2011 to that in 2013?
Ensure brevity in your answer.  1.08. What is the ratio of the Economic output (BoP, current US$) in Burundi in 2012 to that in 2013?
Offer a terse response. 0.9. What is the ratio of the Economic output (BoP, current US$) of Fiji in 2012 to that in 2013?
Offer a very short reply. 1.02. What is the ratio of the Economic output (BoP, current US$) in Portugal in 2012 to that in 2013?
Your answer should be compact. 0.94. What is the difference between the highest and the second highest Economic output (BoP, current US$) of Burundi?
Offer a very short reply. 2.46e+07. What is the difference between the highest and the second highest Economic output (BoP, current US$) of Fiji?
Provide a succinct answer. 5.17e+07. What is the difference between the highest and the second highest Economic output (BoP, current US$) in Portugal?
Keep it short and to the point. 2.97e+08. What is the difference between the highest and the lowest Economic output (BoP, current US$) of Burundi?
Make the answer very short. 9.04e+07. What is the difference between the highest and the lowest Economic output (BoP, current US$) in Fiji?
Provide a short and direct response. 1.77e+08. What is the difference between the highest and the lowest Economic output (BoP, current US$) of Portugal?
Ensure brevity in your answer.  4.50e+09. 